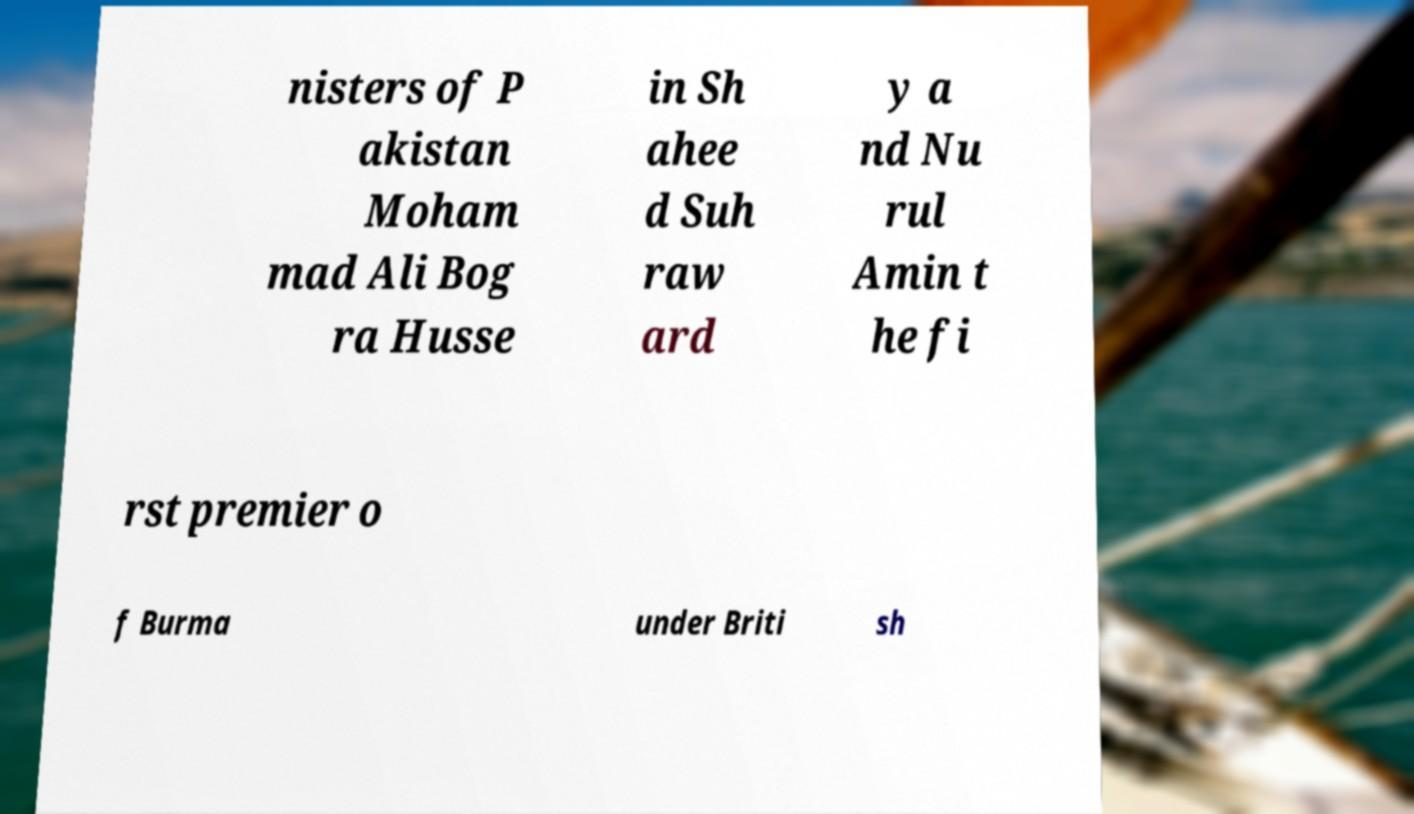Could you assist in decoding the text presented in this image and type it out clearly? nisters of P akistan Moham mad Ali Bog ra Husse in Sh ahee d Suh raw ard y a nd Nu rul Amin t he fi rst premier o f Burma under Briti sh 